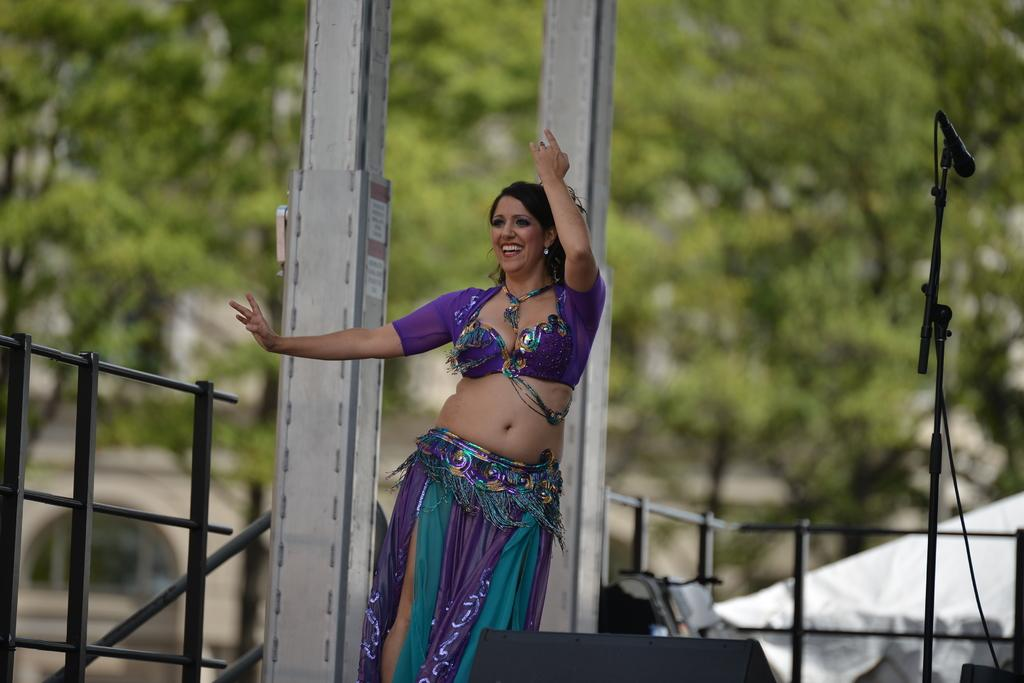Who is the main subject in the image? There is a lady in the center of the image. What is the lady doing in the image? The lady is performing a dance. What expression does the lady have in the image? The lady is smiling. What can be seen in the background of the image? There is railing, a mic with a stand, poles, and trees visible in the background of the image. What type of roof can be seen above the lady in the image? There is no roof visible above the lady in the image; it appears to be an outdoor setting. 